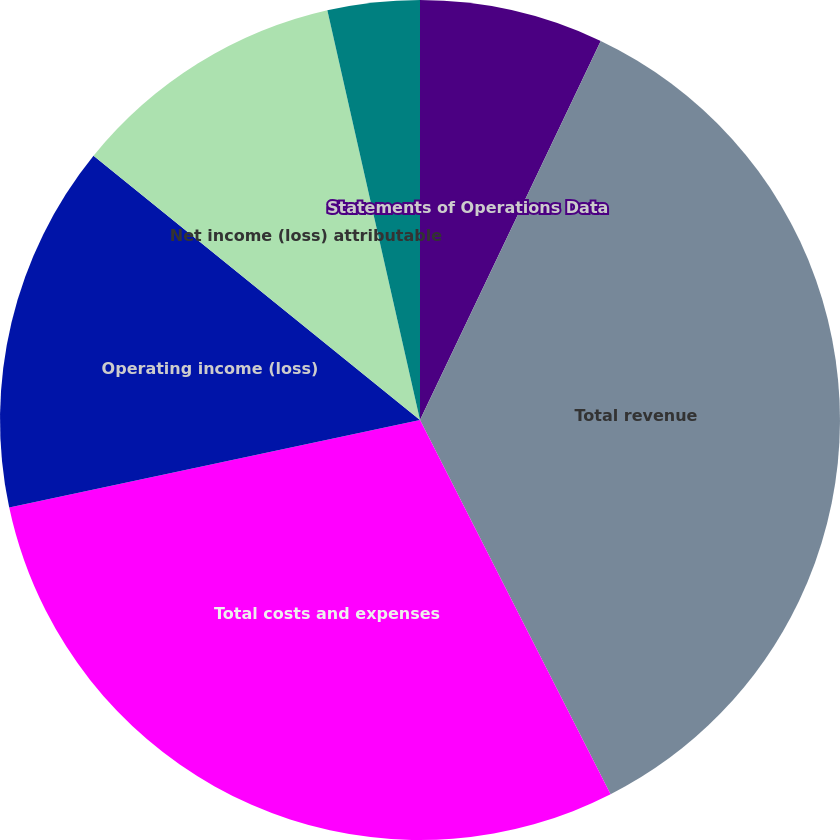<chart> <loc_0><loc_0><loc_500><loc_500><pie_chart><fcel>Statements of Operations Data<fcel>Total revenue<fcel>Total costs and expenses<fcel>Operating income (loss)<fcel>Net income (loss) attributable<fcel>Basic net income (loss) per<fcel>Diluted net income (loss) per<nl><fcel>7.08%<fcel>35.42%<fcel>29.15%<fcel>14.17%<fcel>10.63%<fcel>3.54%<fcel>0.0%<nl></chart> 